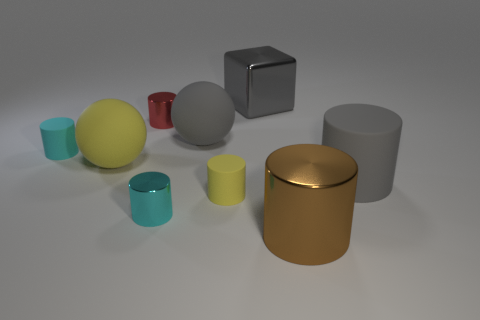Is there any other thing that has the same shape as the cyan metallic thing?
Provide a succinct answer. Yes. Is the number of tiny cyan rubber things behind the cyan rubber thing the same as the number of big yellow matte balls behind the large yellow matte object?
Your response must be concise. Yes. What number of cylinders are either small red rubber things or gray metallic things?
Give a very brief answer. 0. How many other objects are the same material as the yellow sphere?
Keep it short and to the point. 4. There is a large rubber object on the left side of the cyan shiny thing; what shape is it?
Your answer should be compact. Sphere. What is the material of the large thing that is in front of the small rubber thing in front of the tiny cyan matte cylinder?
Offer a terse response. Metal. Is the number of big yellow rubber spheres that are left of the cube greater than the number of cyan rubber objects?
Give a very brief answer. No. How many other things are there of the same color as the large cube?
Ensure brevity in your answer.  2. There is a cyan shiny thing that is the same size as the yellow cylinder; what is its shape?
Ensure brevity in your answer.  Cylinder. There is a tiny cyan cylinder in front of the big gray object that is on the right side of the gray block; how many rubber balls are right of it?
Provide a short and direct response. 1. 